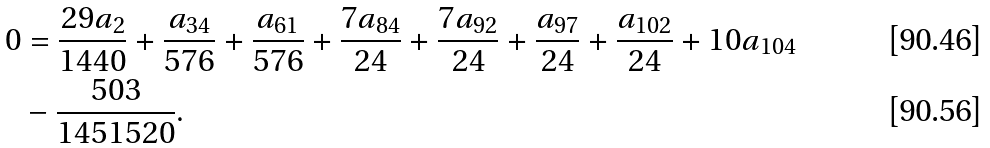<formula> <loc_0><loc_0><loc_500><loc_500>0 & = \frac { 2 9 a _ { 2 } } { 1 4 4 0 } + \frac { a _ { 3 4 } } { 5 7 6 } + \frac { a _ { 6 1 } } { 5 7 6 } + \frac { 7 a _ { 8 4 } } { 2 4 } + \frac { 7 a _ { 9 2 } } { 2 4 } + \frac { a _ { 9 7 } } { 2 4 } + \frac { a _ { 1 0 2 } } { 2 4 } + 1 0 a _ { 1 0 4 } \\ & - \frac { 5 0 3 } { 1 4 5 1 5 2 0 } .</formula> 